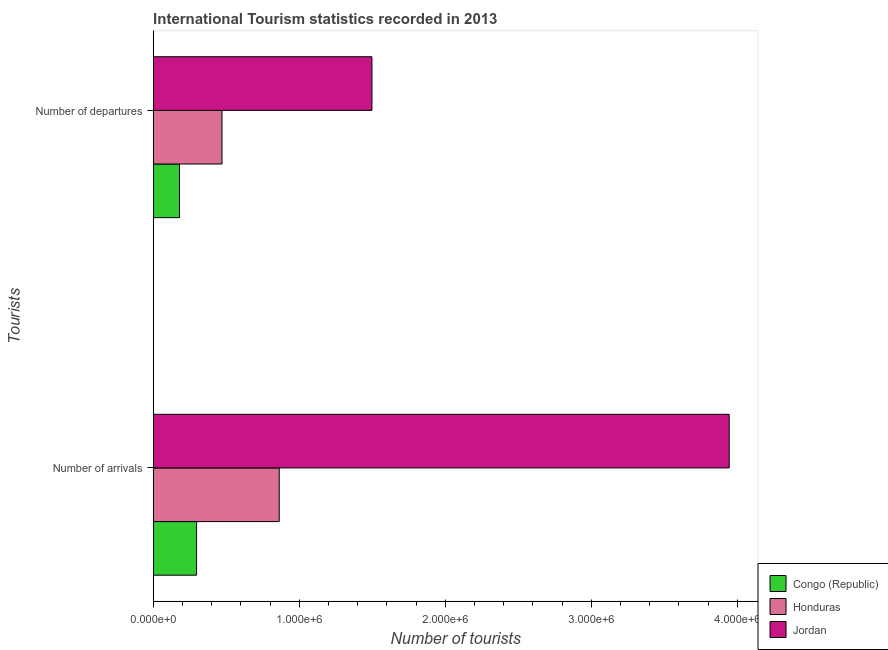How many different coloured bars are there?
Give a very brief answer. 3. Are the number of bars per tick equal to the number of legend labels?
Provide a succinct answer. Yes. What is the label of the 1st group of bars from the top?
Offer a very short reply. Number of departures. What is the number of tourist arrivals in Congo (Republic)?
Offer a very short reply. 2.97e+05. Across all countries, what is the maximum number of tourist departures?
Offer a very short reply. 1.50e+06. Across all countries, what is the minimum number of tourist departures?
Offer a very short reply. 1.80e+05. In which country was the number of tourist departures maximum?
Ensure brevity in your answer.  Jordan. In which country was the number of tourist departures minimum?
Ensure brevity in your answer.  Congo (Republic). What is the total number of tourist departures in the graph?
Provide a succinct answer. 2.15e+06. What is the difference between the number of tourist departures in Jordan and that in Congo (Republic)?
Ensure brevity in your answer.  1.32e+06. What is the difference between the number of tourist arrivals in Jordan and the number of tourist departures in Congo (Republic)?
Your answer should be compact. 3.76e+06. What is the average number of tourist arrivals per country?
Offer a terse response. 1.70e+06. What is the difference between the number of tourist arrivals and number of tourist departures in Jordan?
Keep it short and to the point. 2.45e+06. What is the ratio of the number of tourist departures in Congo (Republic) to that in Jordan?
Offer a very short reply. 0.12. In how many countries, is the number of tourist arrivals greater than the average number of tourist arrivals taken over all countries?
Ensure brevity in your answer.  1. What does the 3rd bar from the top in Number of arrivals represents?
Your answer should be compact. Congo (Republic). What does the 2nd bar from the bottom in Number of departures represents?
Your answer should be very brief. Honduras. How many bars are there?
Provide a succinct answer. 6. What is the difference between two consecutive major ticks on the X-axis?
Provide a short and direct response. 1.00e+06. Are the values on the major ticks of X-axis written in scientific E-notation?
Provide a succinct answer. Yes. Does the graph contain any zero values?
Provide a succinct answer. No. Where does the legend appear in the graph?
Keep it short and to the point. Bottom right. How many legend labels are there?
Make the answer very short. 3. How are the legend labels stacked?
Provide a succinct answer. Vertical. What is the title of the graph?
Give a very brief answer. International Tourism statistics recorded in 2013. Does "Sub-Saharan Africa (all income levels)" appear as one of the legend labels in the graph?
Provide a succinct answer. No. What is the label or title of the X-axis?
Make the answer very short. Number of tourists. What is the label or title of the Y-axis?
Make the answer very short. Tourists. What is the Number of tourists in Congo (Republic) in Number of arrivals?
Offer a very short reply. 2.97e+05. What is the Number of tourists in Honduras in Number of arrivals?
Keep it short and to the point. 8.63e+05. What is the Number of tourists of Jordan in Number of arrivals?
Give a very brief answer. 3.94e+06. What is the Number of tourists of Honduras in Number of departures?
Provide a short and direct response. 4.71e+05. What is the Number of tourists of Jordan in Number of departures?
Make the answer very short. 1.50e+06. Across all Tourists, what is the maximum Number of tourists of Congo (Republic)?
Ensure brevity in your answer.  2.97e+05. Across all Tourists, what is the maximum Number of tourists in Honduras?
Offer a terse response. 8.63e+05. Across all Tourists, what is the maximum Number of tourists in Jordan?
Your answer should be very brief. 3.94e+06. Across all Tourists, what is the minimum Number of tourists in Congo (Republic)?
Your response must be concise. 1.80e+05. Across all Tourists, what is the minimum Number of tourists of Honduras?
Provide a succinct answer. 4.71e+05. Across all Tourists, what is the minimum Number of tourists in Jordan?
Make the answer very short. 1.50e+06. What is the total Number of tourists of Congo (Republic) in the graph?
Give a very brief answer. 4.77e+05. What is the total Number of tourists of Honduras in the graph?
Ensure brevity in your answer.  1.33e+06. What is the total Number of tourists of Jordan in the graph?
Your response must be concise. 5.44e+06. What is the difference between the Number of tourists in Congo (Republic) in Number of arrivals and that in Number of departures?
Make the answer very short. 1.17e+05. What is the difference between the Number of tourists in Honduras in Number of arrivals and that in Number of departures?
Ensure brevity in your answer.  3.92e+05. What is the difference between the Number of tourists of Jordan in Number of arrivals and that in Number of departures?
Keep it short and to the point. 2.45e+06. What is the difference between the Number of tourists in Congo (Republic) in Number of arrivals and the Number of tourists in Honduras in Number of departures?
Your answer should be compact. -1.74e+05. What is the difference between the Number of tourists of Congo (Republic) in Number of arrivals and the Number of tourists of Jordan in Number of departures?
Your answer should be very brief. -1.20e+06. What is the difference between the Number of tourists of Honduras in Number of arrivals and the Number of tourists of Jordan in Number of departures?
Your response must be concise. -6.35e+05. What is the average Number of tourists of Congo (Republic) per Tourists?
Make the answer very short. 2.38e+05. What is the average Number of tourists of Honduras per Tourists?
Provide a succinct answer. 6.67e+05. What is the average Number of tourists of Jordan per Tourists?
Keep it short and to the point. 2.72e+06. What is the difference between the Number of tourists of Congo (Republic) and Number of tourists of Honduras in Number of arrivals?
Give a very brief answer. -5.66e+05. What is the difference between the Number of tourists in Congo (Republic) and Number of tourists in Jordan in Number of arrivals?
Offer a terse response. -3.65e+06. What is the difference between the Number of tourists of Honduras and Number of tourists of Jordan in Number of arrivals?
Your answer should be very brief. -3.08e+06. What is the difference between the Number of tourists of Congo (Republic) and Number of tourists of Honduras in Number of departures?
Offer a terse response. -2.91e+05. What is the difference between the Number of tourists of Congo (Republic) and Number of tourists of Jordan in Number of departures?
Provide a succinct answer. -1.32e+06. What is the difference between the Number of tourists in Honduras and Number of tourists in Jordan in Number of departures?
Offer a terse response. -1.03e+06. What is the ratio of the Number of tourists in Congo (Republic) in Number of arrivals to that in Number of departures?
Give a very brief answer. 1.65. What is the ratio of the Number of tourists of Honduras in Number of arrivals to that in Number of departures?
Your answer should be compact. 1.83. What is the ratio of the Number of tourists in Jordan in Number of arrivals to that in Number of departures?
Ensure brevity in your answer.  2.63. What is the difference between the highest and the second highest Number of tourists in Congo (Republic)?
Provide a short and direct response. 1.17e+05. What is the difference between the highest and the second highest Number of tourists in Honduras?
Keep it short and to the point. 3.92e+05. What is the difference between the highest and the second highest Number of tourists in Jordan?
Offer a very short reply. 2.45e+06. What is the difference between the highest and the lowest Number of tourists of Congo (Republic)?
Ensure brevity in your answer.  1.17e+05. What is the difference between the highest and the lowest Number of tourists of Honduras?
Make the answer very short. 3.92e+05. What is the difference between the highest and the lowest Number of tourists of Jordan?
Your answer should be compact. 2.45e+06. 